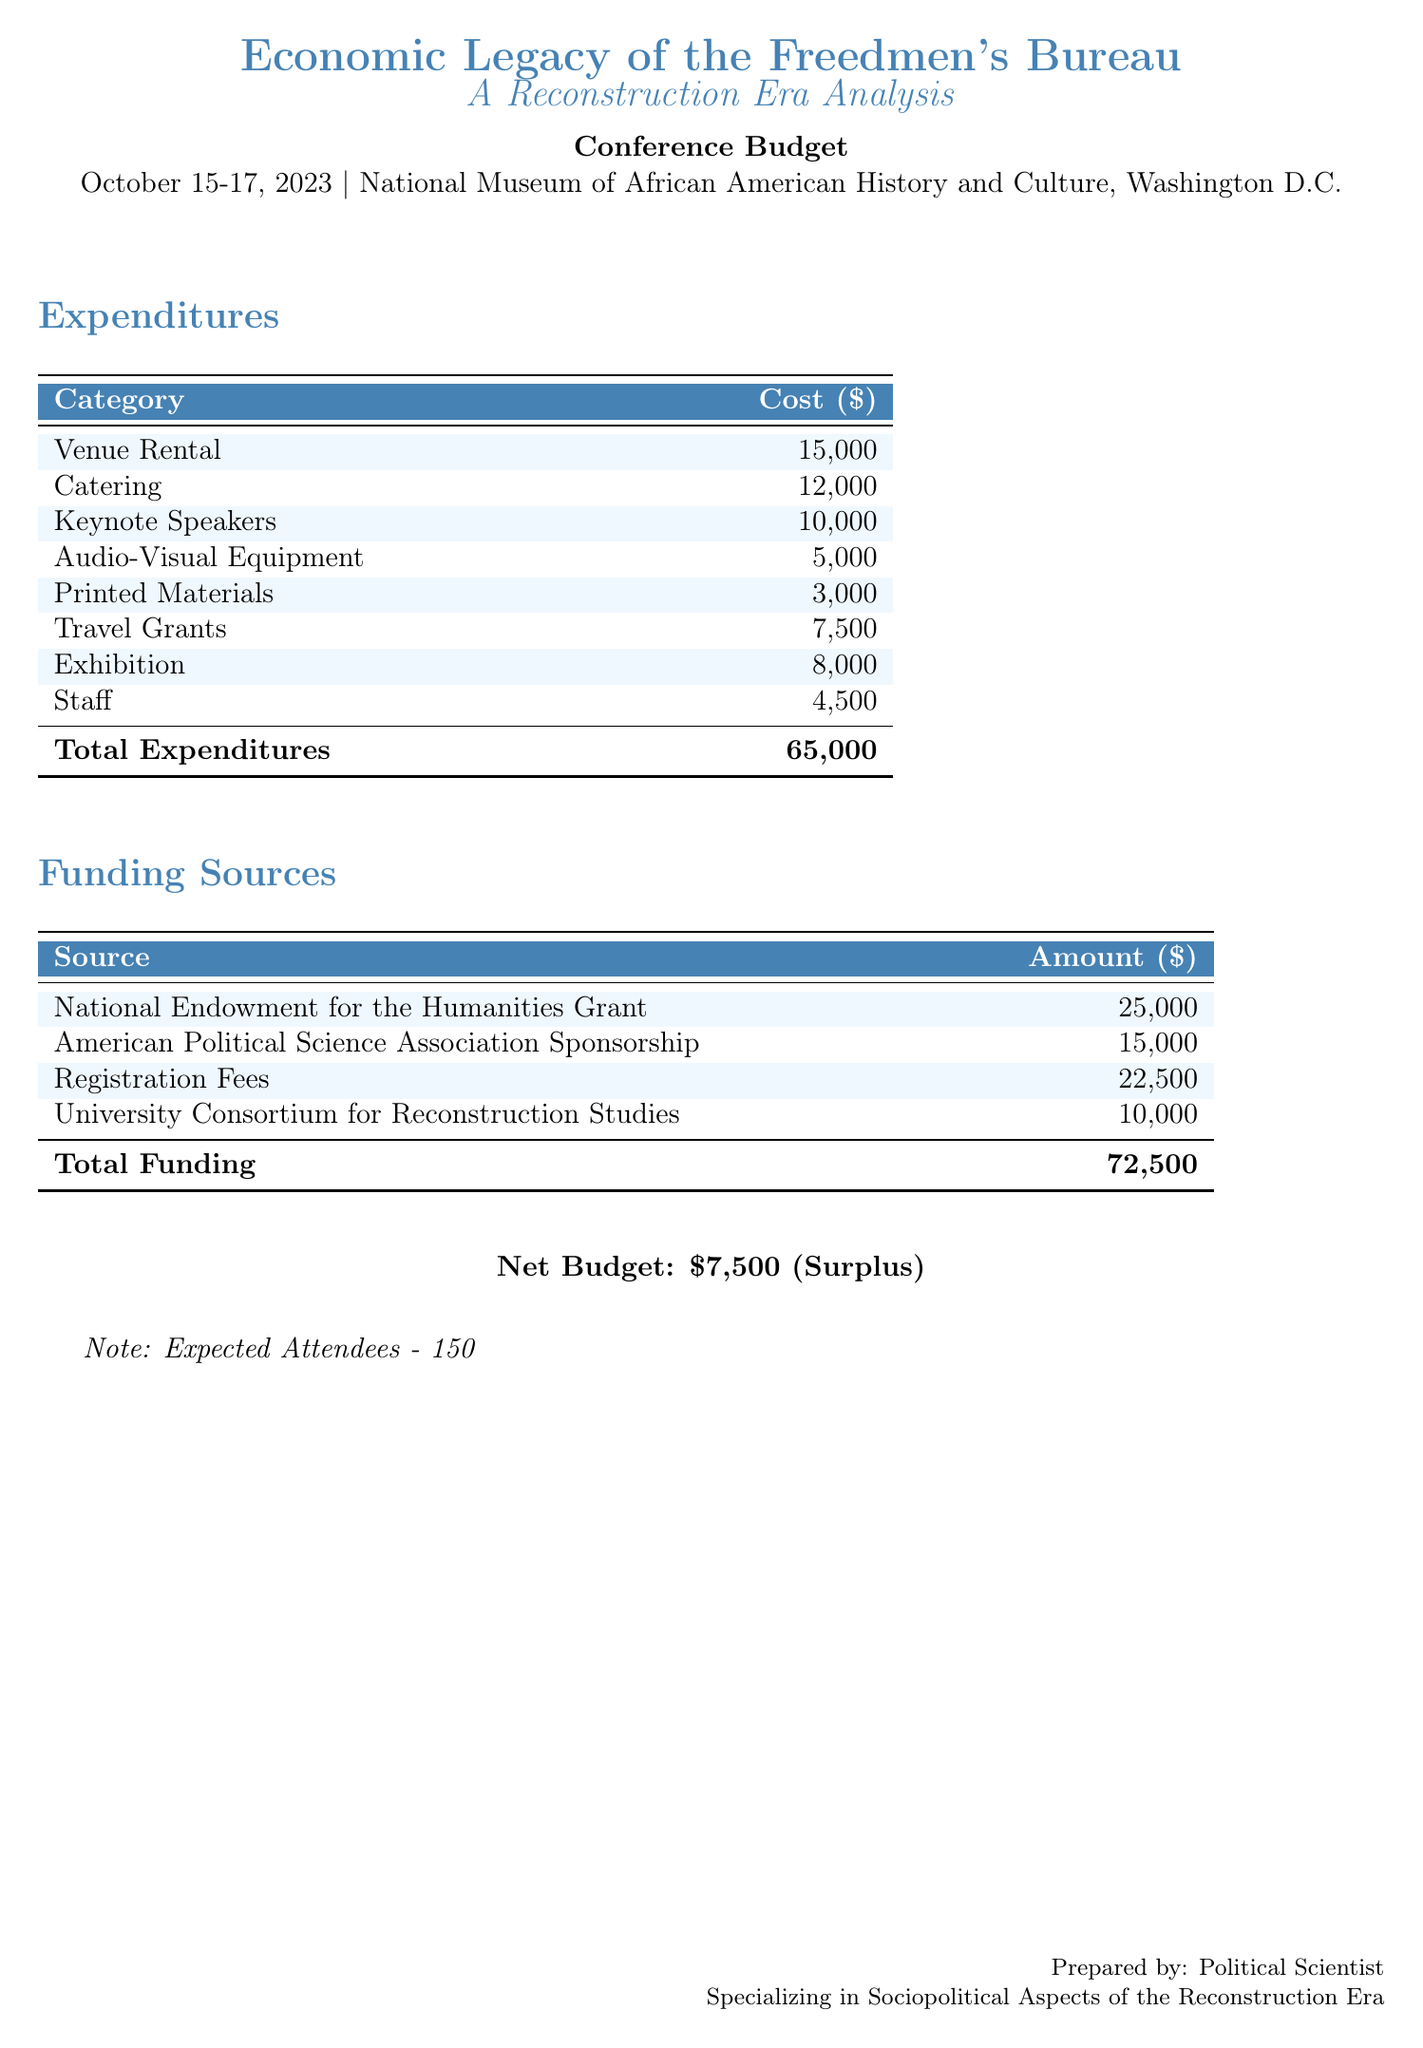What is the total cost of keynote speakers? The total cost for keynote speakers is specified directly in the expenditures table as $10,000.
Answer: $10,000 What is the venue rental cost? The cost of venue rental is listed in the expenditures section of the document, which shows it as $15,000.
Answer: $15,000 What is the total funding amount? The total funding is calculated by summing all the funding sources listed, which amounts to $72,500.
Answer: $72,500 What is the net budget surplus? The net budget is shown at the end of the document as a surplus of $7,500 after calculating total expenditures versus total funding.
Answer: $7,500 How many expected attendees are there? The document clearly states the expected number of attendees, which is 150.
Answer: 150 What is the cost for audio-visual equipment? The cost for audio-visual equipment is mentioned in the expenditures table as $5,000.
Answer: $5,000 What is the source of the largest funding? The largest funding source is the National Endowment for the Humanities Grant listed at $25,000.
Answer: National Endowment for the Humanities Grant What is the total expenditure amount? The total expenditure is calculated from the expenditures listed and totals $65,000.
Answer: $65,000 What is the cost allocated for travel grants? The cost allocated for travel grants is stated in the expenditures section as $7,500.
Answer: $7,500 